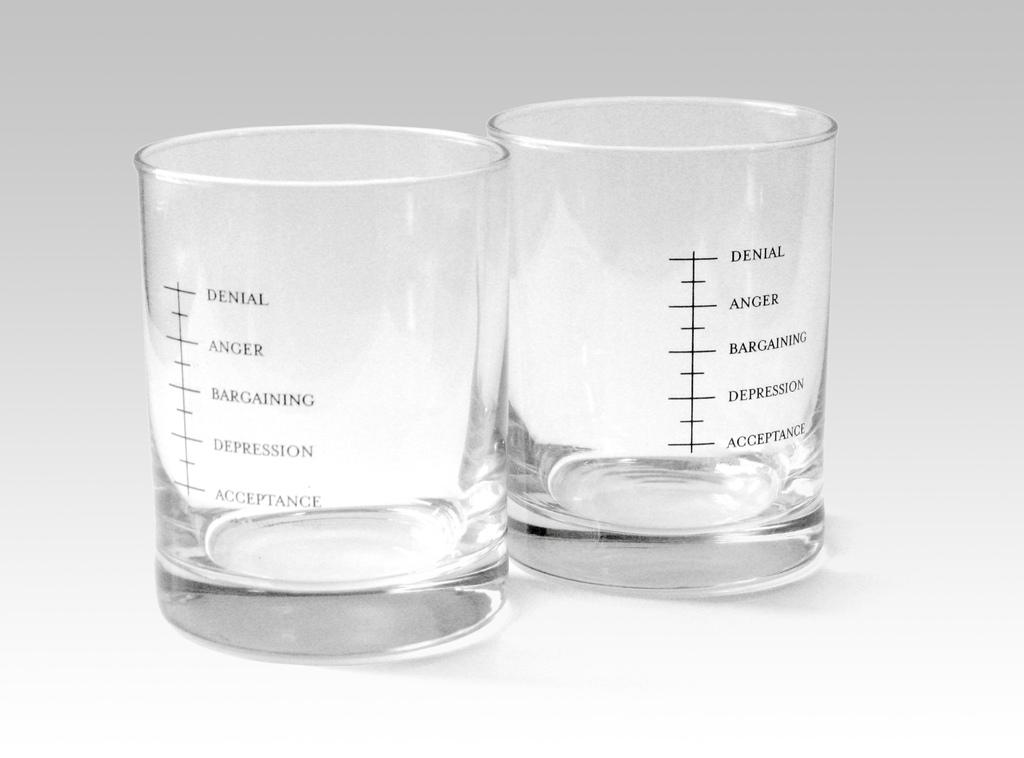What is at the top of the glass?
Provide a short and direct response. Denial. What does the right glass say?
Give a very brief answer. Denial anger bargaining depression acceptance. 